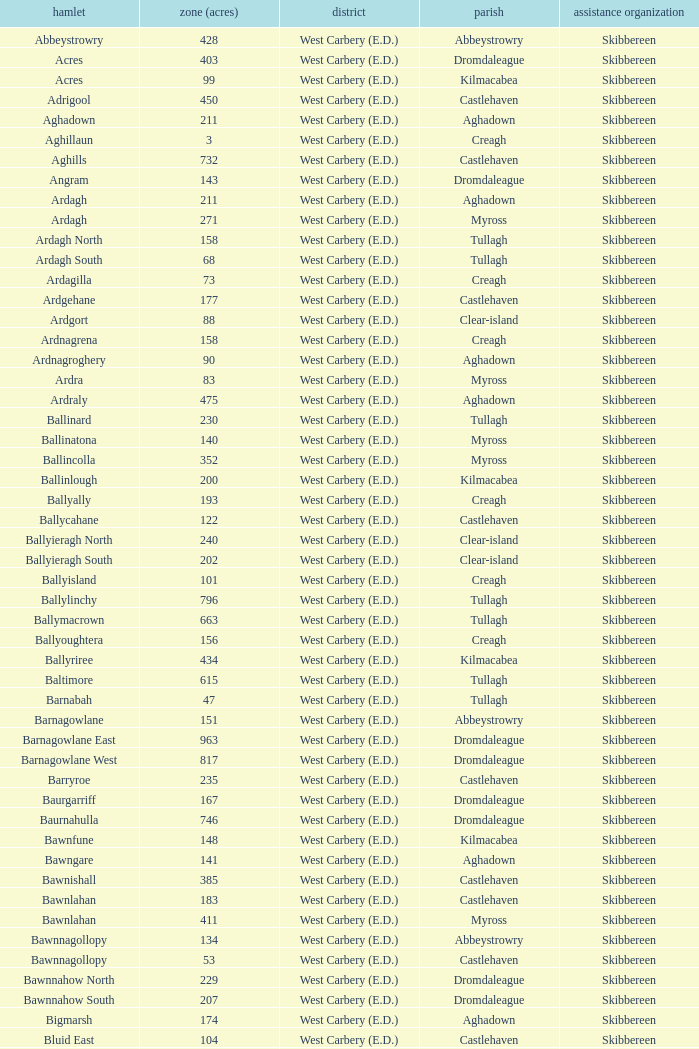What are the areas (in acres) of the Kilnahera East townland? 257.0. 